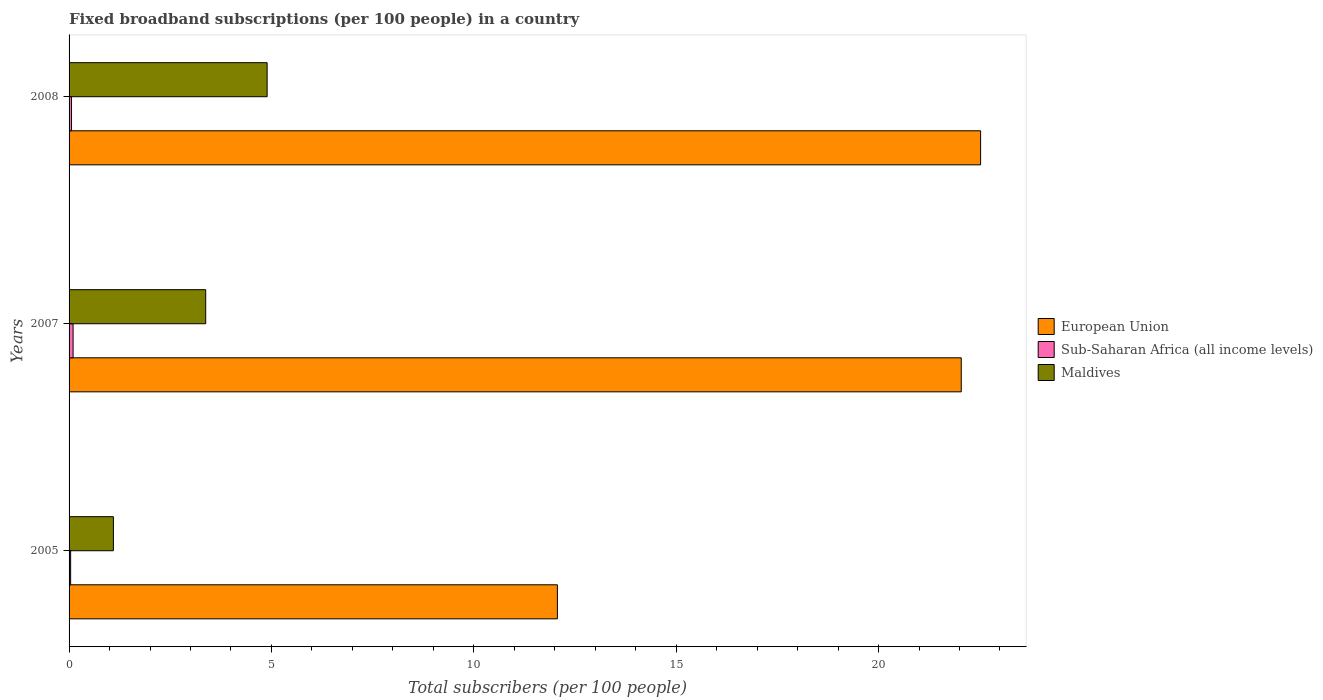How many different coloured bars are there?
Provide a short and direct response. 3. How many groups of bars are there?
Give a very brief answer. 3. Are the number of bars on each tick of the Y-axis equal?
Make the answer very short. Yes. How many bars are there on the 1st tick from the top?
Provide a succinct answer. 3. How many bars are there on the 2nd tick from the bottom?
Make the answer very short. 3. What is the label of the 2nd group of bars from the top?
Offer a very short reply. 2007. What is the number of broadband subscriptions in Maldives in 2005?
Provide a short and direct response. 1.1. Across all years, what is the maximum number of broadband subscriptions in European Union?
Give a very brief answer. 22.52. Across all years, what is the minimum number of broadband subscriptions in European Union?
Make the answer very short. 12.07. In which year was the number of broadband subscriptions in Maldives maximum?
Offer a terse response. 2008. What is the total number of broadband subscriptions in European Union in the graph?
Your answer should be compact. 56.63. What is the difference between the number of broadband subscriptions in European Union in 2007 and that in 2008?
Ensure brevity in your answer.  -0.48. What is the difference between the number of broadband subscriptions in European Union in 2005 and the number of broadband subscriptions in Maldives in 2008?
Offer a terse response. 7.17. What is the average number of broadband subscriptions in Sub-Saharan Africa (all income levels) per year?
Provide a short and direct response. 0.07. In the year 2005, what is the difference between the number of broadband subscriptions in Maldives and number of broadband subscriptions in European Union?
Offer a terse response. -10.97. In how many years, is the number of broadband subscriptions in Maldives greater than 13 ?
Offer a very short reply. 0. What is the ratio of the number of broadband subscriptions in Maldives in 2005 to that in 2007?
Your answer should be compact. 0.32. Is the number of broadband subscriptions in European Union in 2005 less than that in 2007?
Offer a very short reply. Yes. What is the difference between the highest and the second highest number of broadband subscriptions in Sub-Saharan Africa (all income levels)?
Ensure brevity in your answer.  0.04. What is the difference between the highest and the lowest number of broadband subscriptions in Maldives?
Make the answer very short. 3.8. What does the 2nd bar from the top in 2007 represents?
Ensure brevity in your answer.  Sub-Saharan Africa (all income levels). Is it the case that in every year, the sum of the number of broadband subscriptions in Sub-Saharan Africa (all income levels) and number of broadband subscriptions in European Union is greater than the number of broadband subscriptions in Maldives?
Your response must be concise. Yes. How many bars are there?
Provide a short and direct response. 9. How many years are there in the graph?
Offer a terse response. 3. What is the difference between two consecutive major ticks on the X-axis?
Ensure brevity in your answer.  5. Are the values on the major ticks of X-axis written in scientific E-notation?
Your answer should be very brief. No. Does the graph contain grids?
Keep it short and to the point. No. Where does the legend appear in the graph?
Your answer should be compact. Center right. How are the legend labels stacked?
Your answer should be compact. Vertical. What is the title of the graph?
Offer a very short reply. Fixed broadband subscriptions (per 100 people) in a country. Does "Kenya" appear as one of the legend labels in the graph?
Give a very brief answer. No. What is the label or title of the X-axis?
Offer a very short reply. Total subscribers (per 100 people). What is the Total subscribers (per 100 people) of European Union in 2005?
Give a very brief answer. 12.07. What is the Total subscribers (per 100 people) in Sub-Saharan Africa (all income levels) in 2005?
Your response must be concise. 0.04. What is the Total subscribers (per 100 people) in Maldives in 2005?
Give a very brief answer. 1.1. What is the Total subscribers (per 100 people) in European Union in 2007?
Your answer should be very brief. 22.04. What is the Total subscribers (per 100 people) in Sub-Saharan Africa (all income levels) in 2007?
Your answer should be compact. 0.1. What is the Total subscribers (per 100 people) in Maldives in 2007?
Provide a succinct answer. 3.38. What is the Total subscribers (per 100 people) of European Union in 2008?
Your response must be concise. 22.52. What is the Total subscribers (per 100 people) in Sub-Saharan Africa (all income levels) in 2008?
Make the answer very short. 0.06. What is the Total subscribers (per 100 people) in Maldives in 2008?
Keep it short and to the point. 4.89. Across all years, what is the maximum Total subscribers (per 100 people) in European Union?
Offer a terse response. 22.52. Across all years, what is the maximum Total subscribers (per 100 people) of Sub-Saharan Africa (all income levels)?
Provide a succinct answer. 0.1. Across all years, what is the maximum Total subscribers (per 100 people) of Maldives?
Ensure brevity in your answer.  4.89. Across all years, what is the minimum Total subscribers (per 100 people) of European Union?
Offer a very short reply. 12.07. Across all years, what is the minimum Total subscribers (per 100 people) of Sub-Saharan Africa (all income levels)?
Offer a very short reply. 0.04. Across all years, what is the minimum Total subscribers (per 100 people) in Maldives?
Offer a terse response. 1.1. What is the total Total subscribers (per 100 people) of European Union in the graph?
Give a very brief answer. 56.63. What is the total Total subscribers (per 100 people) of Sub-Saharan Africa (all income levels) in the graph?
Give a very brief answer. 0.2. What is the total Total subscribers (per 100 people) of Maldives in the graph?
Offer a terse response. 9.37. What is the difference between the Total subscribers (per 100 people) of European Union in 2005 and that in 2007?
Make the answer very short. -9.98. What is the difference between the Total subscribers (per 100 people) in Sub-Saharan Africa (all income levels) in 2005 and that in 2007?
Your response must be concise. -0.06. What is the difference between the Total subscribers (per 100 people) of Maldives in 2005 and that in 2007?
Your answer should be compact. -2.28. What is the difference between the Total subscribers (per 100 people) of European Union in 2005 and that in 2008?
Your answer should be compact. -10.46. What is the difference between the Total subscribers (per 100 people) in Sub-Saharan Africa (all income levels) in 2005 and that in 2008?
Make the answer very short. -0.02. What is the difference between the Total subscribers (per 100 people) of Maldives in 2005 and that in 2008?
Ensure brevity in your answer.  -3.8. What is the difference between the Total subscribers (per 100 people) of European Union in 2007 and that in 2008?
Ensure brevity in your answer.  -0.48. What is the difference between the Total subscribers (per 100 people) of Sub-Saharan Africa (all income levels) in 2007 and that in 2008?
Ensure brevity in your answer.  0.04. What is the difference between the Total subscribers (per 100 people) of Maldives in 2007 and that in 2008?
Make the answer very short. -1.52. What is the difference between the Total subscribers (per 100 people) of European Union in 2005 and the Total subscribers (per 100 people) of Sub-Saharan Africa (all income levels) in 2007?
Keep it short and to the point. 11.97. What is the difference between the Total subscribers (per 100 people) in European Union in 2005 and the Total subscribers (per 100 people) in Maldives in 2007?
Offer a very short reply. 8.69. What is the difference between the Total subscribers (per 100 people) of Sub-Saharan Africa (all income levels) in 2005 and the Total subscribers (per 100 people) of Maldives in 2007?
Your response must be concise. -3.34. What is the difference between the Total subscribers (per 100 people) of European Union in 2005 and the Total subscribers (per 100 people) of Sub-Saharan Africa (all income levels) in 2008?
Your answer should be very brief. 12. What is the difference between the Total subscribers (per 100 people) of European Union in 2005 and the Total subscribers (per 100 people) of Maldives in 2008?
Your answer should be very brief. 7.17. What is the difference between the Total subscribers (per 100 people) in Sub-Saharan Africa (all income levels) in 2005 and the Total subscribers (per 100 people) in Maldives in 2008?
Provide a succinct answer. -4.86. What is the difference between the Total subscribers (per 100 people) in European Union in 2007 and the Total subscribers (per 100 people) in Sub-Saharan Africa (all income levels) in 2008?
Keep it short and to the point. 21.98. What is the difference between the Total subscribers (per 100 people) in European Union in 2007 and the Total subscribers (per 100 people) in Maldives in 2008?
Offer a terse response. 17.15. What is the difference between the Total subscribers (per 100 people) in Sub-Saharan Africa (all income levels) in 2007 and the Total subscribers (per 100 people) in Maldives in 2008?
Make the answer very short. -4.79. What is the average Total subscribers (per 100 people) in European Union per year?
Offer a very short reply. 18.88. What is the average Total subscribers (per 100 people) in Sub-Saharan Africa (all income levels) per year?
Provide a short and direct response. 0.07. What is the average Total subscribers (per 100 people) in Maldives per year?
Provide a succinct answer. 3.12. In the year 2005, what is the difference between the Total subscribers (per 100 people) of European Union and Total subscribers (per 100 people) of Sub-Saharan Africa (all income levels)?
Provide a succinct answer. 12.03. In the year 2005, what is the difference between the Total subscribers (per 100 people) of European Union and Total subscribers (per 100 people) of Maldives?
Provide a succinct answer. 10.97. In the year 2005, what is the difference between the Total subscribers (per 100 people) in Sub-Saharan Africa (all income levels) and Total subscribers (per 100 people) in Maldives?
Your answer should be compact. -1.06. In the year 2007, what is the difference between the Total subscribers (per 100 people) in European Union and Total subscribers (per 100 people) in Sub-Saharan Africa (all income levels)?
Your answer should be very brief. 21.94. In the year 2007, what is the difference between the Total subscribers (per 100 people) in European Union and Total subscribers (per 100 people) in Maldives?
Your answer should be compact. 18.67. In the year 2007, what is the difference between the Total subscribers (per 100 people) of Sub-Saharan Africa (all income levels) and Total subscribers (per 100 people) of Maldives?
Keep it short and to the point. -3.28. In the year 2008, what is the difference between the Total subscribers (per 100 people) in European Union and Total subscribers (per 100 people) in Sub-Saharan Africa (all income levels)?
Provide a succinct answer. 22.46. In the year 2008, what is the difference between the Total subscribers (per 100 people) of European Union and Total subscribers (per 100 people) of Maldives?
Offer a very short reply. 17.63. In the year 2008, what is the difference between the Total subscribers (per 100 people) of Sub-Saharan Africa (all income levels) and Total subscribers (per 100 people) of Maldives?
Your answer should be compact. -4.83. What is the ratio of the Total subscribers (per 100 people) in European Union in 2005 to that in 2007?
Provide a succinct answer. 0.55. What is the ratio of the Total subscribers (per 100 people) in Sub-Saharan Africa (all income levels) in 2005 to that in 2007?
Your answer should be compact. 0.39. What is the ratio of the Total subscribers (per 100 people) of Maldives in 2005 to that in 2007?
Provide a short and direct response. 0.32. What is the ratio of the Total subscribers (per 100 people) in European Union in 2005 to that in 2008?
Make the answer very short. 0.54. What is the ratio of the Total subscribers (per 100 people) of Sub-Saharan Africa (all income levels) in 2005 to that in 2008?
Offer a very short reply. 0.64. What is the ratio of the Total subscribers (per 100 people) of Maldives in 2005 to that in 2008?
Ensure brevity in your answer.  0.22. What is the ratio of the Total subscribers (per 100 people) in European Union in 2007 to that in 2008?
Make the answer very short. 0.98. What is the ratio of the Total subscribers (per 100 people) of Sub-Saharan Africa (all income levels) in 2007 to that in 2008?
Make the answer very short. 1.64. What is the ratio of the Total subscribers (per 100 people) of Maldives in 2007 to that in 2008?
Provide a succinct answer. 0.69. What is the difference between the highest and the second highest Total subscribers (per 100 people) in European Union?
Make the answer very short. 0.48. What is the difference between the highest and the second highest Total subscribers (per 100 people) of Sub-Saharan Africa (all income levels)?
Your answer should be compact. 0.04. What is the difference between the highest and the second highest Total subscribers (per 100 people) in Maldives?
Offer a terse response. 1.52. What is the difference between the highest and the lowest Total subscribers (per 100 people) in European Union?
Provide a succinct answer. 10.46. What is the difference between the highest and the lowest Total subscribers (per 100 people) in Sub-Saharan Africa (all income levels)?
Your response must be concise. 0.06. What is the difference between the highest and the lowest Total subscribers (per 100 people) in Maldives?
Offer a terse response. 3.8. 